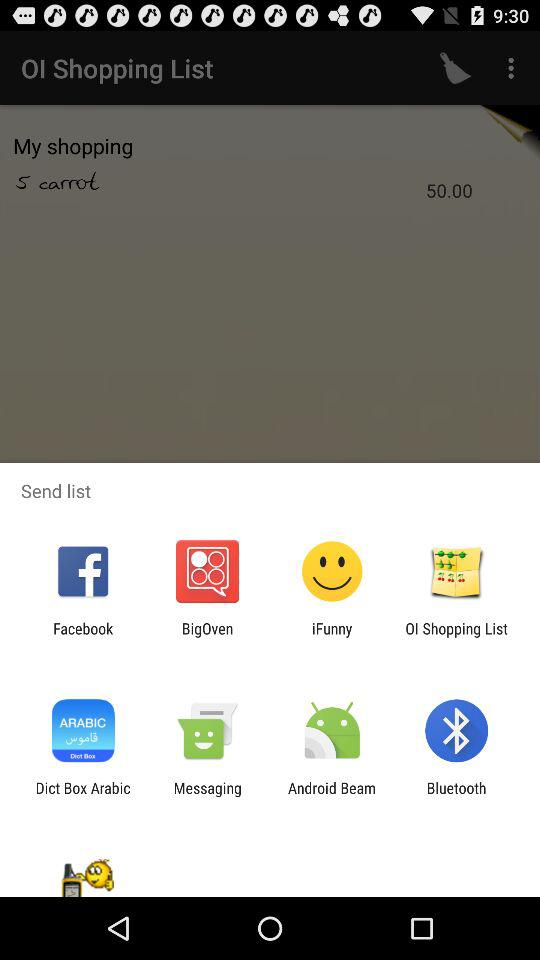What applications are there in the send list? The applications in the send list are "Facebook", "BigOven", "iFunny", "OI Shopping List", "Dict Box Arabic", " Messaging", "Android Beam", and "Bluetooth". 